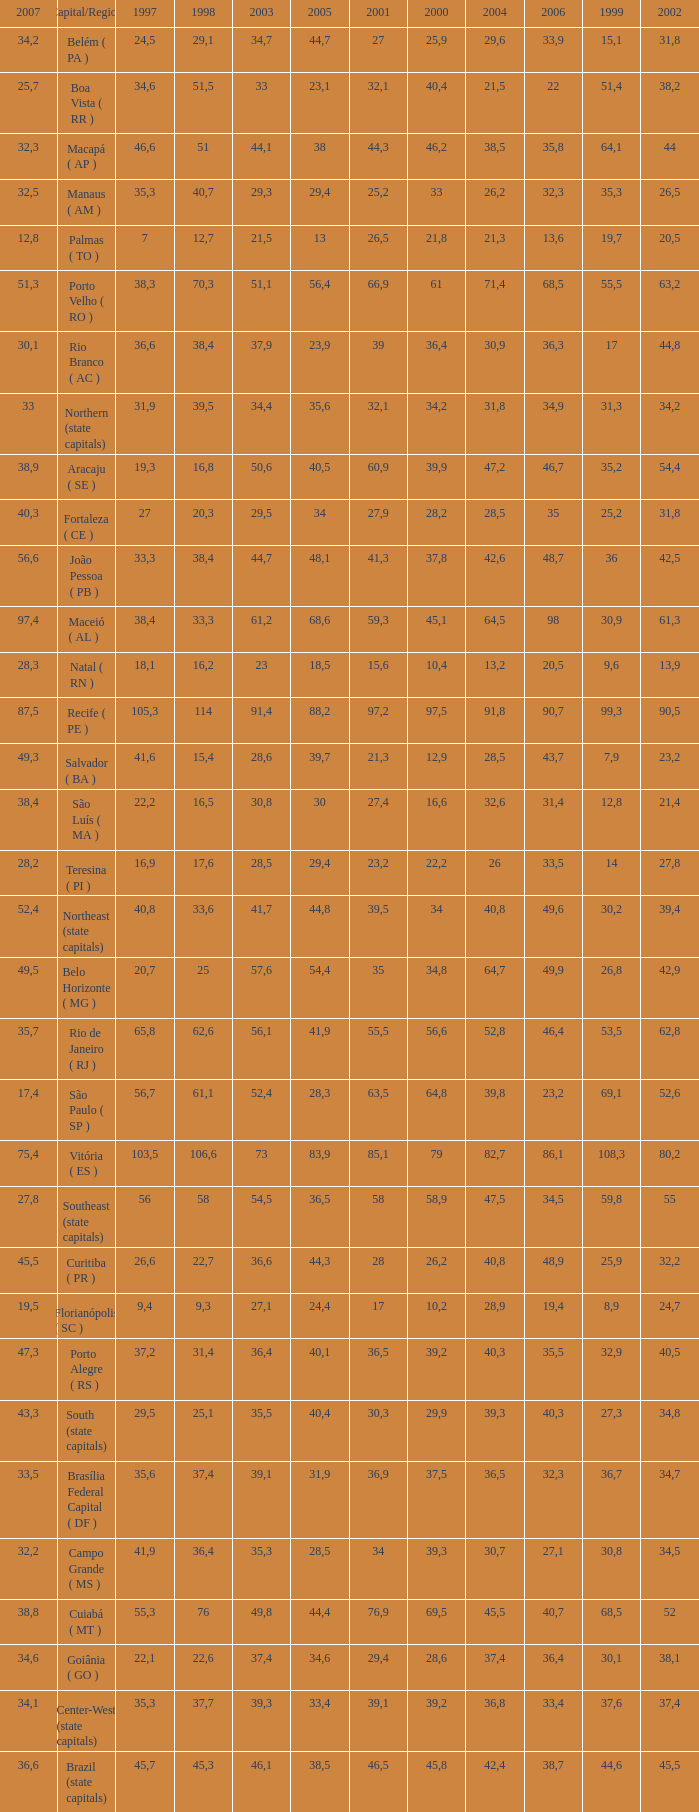What is the average 2000 that has a 1997 greater than 34,6, a 2006 greater than 38,7, and a 2998 less than 76? 41.92. 